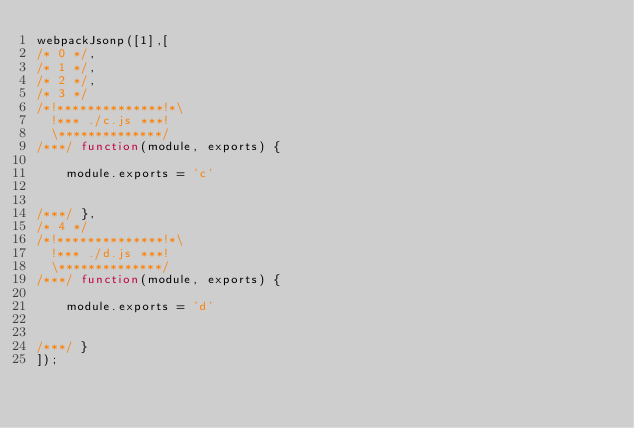<code> <loc_0><loc_0><loc_500><loc_500><_JavaScript_>webpackJsonp([1],[
/* 0 */,
/* 1 */,
/* 2 */,
/* 3 */
/*!**************!*\
  !*** ./c.js ***!
  \**************/
/***/ function(module, exports) {

	module.exports = 'c'


/***/ },
/* 4 */
/*!**************!*\
  !*** ./d.js ***!
  \**************/
/***/ function(module, exports) {

	module.exports = 'd'


/***/ }
]);</code> 